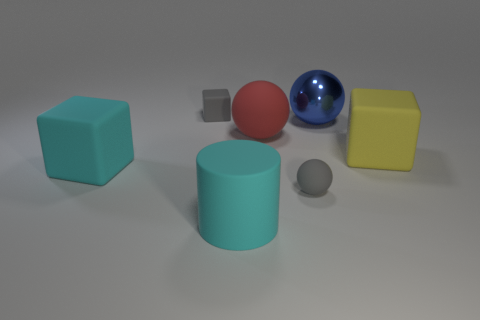Add 1 red rubber blocks. How many objects exist? 8 Subtract all big blocks. How many blocks are left? 1 Subtract all cubes. How many objects are left? 4 Add 7 big yellow rubber objects. How many big yellow rubber objects are left? 8 Add 1 small gray balls. How many small gray balls exist? 2 Subtract 0 brown cylinders. How many objects are left? 7 Subtract all cyan spheres. Subtract all brown cubes. How many spheres are left? 3 Subtract all purple shiny cylinders. Subtract all tiny objects. How many objects are left? 5 